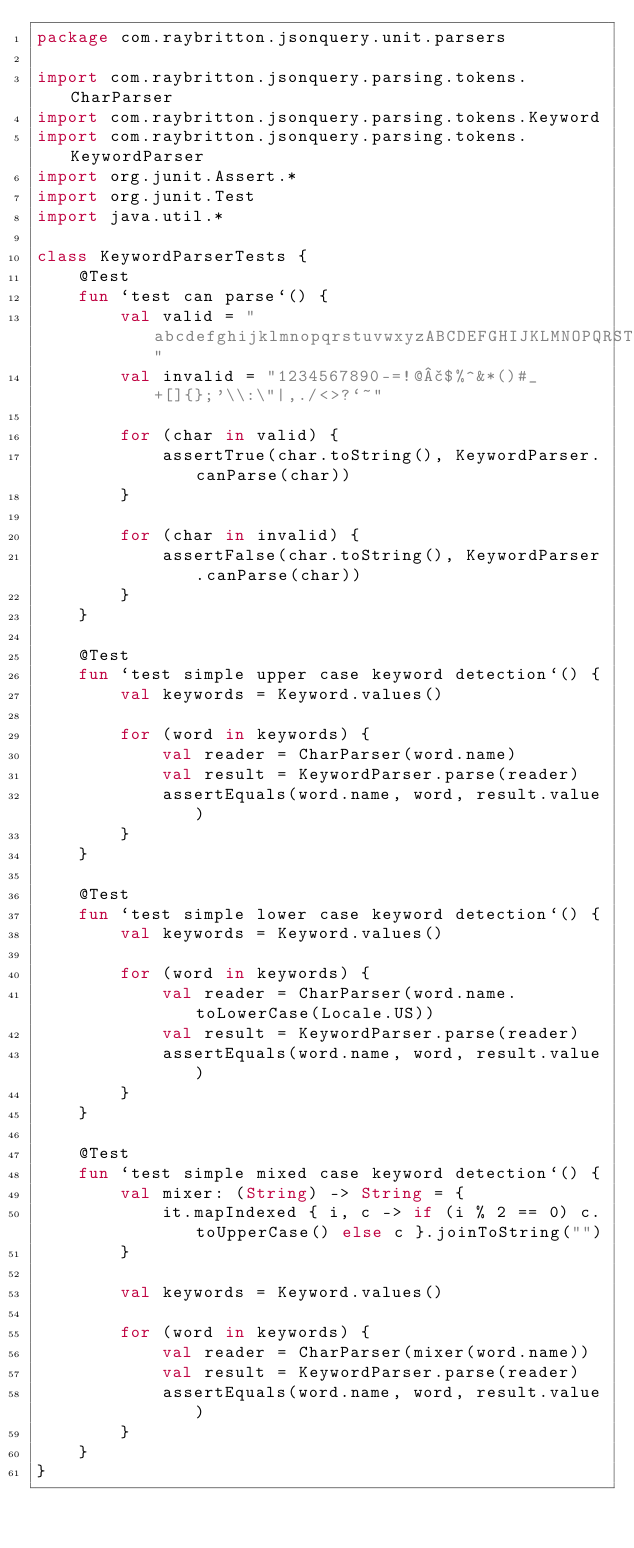<code> <loc_0><loc_0><loc_500><loc_500><_Kotlin_>package com.raybritton.jsonquery.unit.parsers

import com.raybritton.jsonquery.parsing.tokens.CharParser
import com.raybritton.jsonquery.parsing.tokens.Keyword
import com.raybritton.jsonquery.parsing.tokens.KeywordParser
import org.junit.Assert.*
import org.junit.Test
import java.util.*

class KeywordParserTests {
    @Test
    fun `test can parse`() {
        val valid = "abcdefghijklmnopqrstuvwxyzABCDEFGHIJKLMNOPQRSTUVWXYZ"
        val invalid = "1234567890-=!@£$%^&*()#_+[]{};'\\:\"|,./<>?`~"

        for (char in valid) {
            assertTrue(char.toString(), KeywordParser.canParse(char))
        }

        for (char in invalid) {
            assertFalse(char.toString(), KeywordParser.canParse(char))
        }
    }

    @Test
    fun `test simple upper case keyword detection`() {
        val keywords = Keyword.values()

        for (word in keywords) {
            val reader = CharParser(word.name)
            val result = KeywordParser.parse(reader)
            assertEquals(word.name, word, result.value)
        }
    }

    @Test
    fun `test simple lower case keyword detection`() {
        val keywords = Keyword.values()

        for (word in keywords) {
            val reader = CharParser(word.name.toLowerCase(Locale.US))
            val result = KeywordParser.parse(reader)
            assertEquals(word.name, word, result.value)
        }
    }

    @Test
    fun `test simple mixed case keyword detection`() {
        val mixer: (String) -> String = {
            it.mapIndexed { i, c -> if (i % 2 == 0) c.toUpperCase() else c }.joinToString("")
        }

        val keywords = Keyword.values()

        for (word in keywords) {
            val reader = CharParser(mixer(word.name))
            val result = KeywordParser.parse(reader)
            assertEquals(word.name, word, result.value)
        }
    }
}</code> 